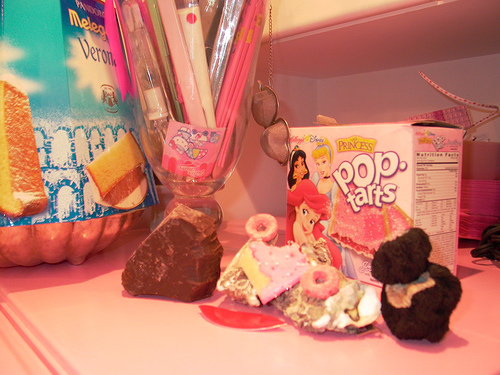<image>
Is there a princess behind the mermaid? Yes. From this viewpoint, the princess is positioned behind the mermaid, with the mermaid partially or fully occluding the princess. Is the jasmine to the right of the froot loop? No. The jasmine is not to the right of the froot loop. The horizontal positioning shows a different relationship. Is there a rock in the vase? No. The rock is not contained within the vase. These objects have a different spatial relationship. 